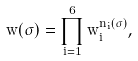<formula> <loc_0><loc_0><loc_500><loc_500>w ( \sigma ) = \prod _ { i = 1 } ^ { 6 } w _ { i } ^ { n _ { i } ( \sigma ) } ,</formula> 